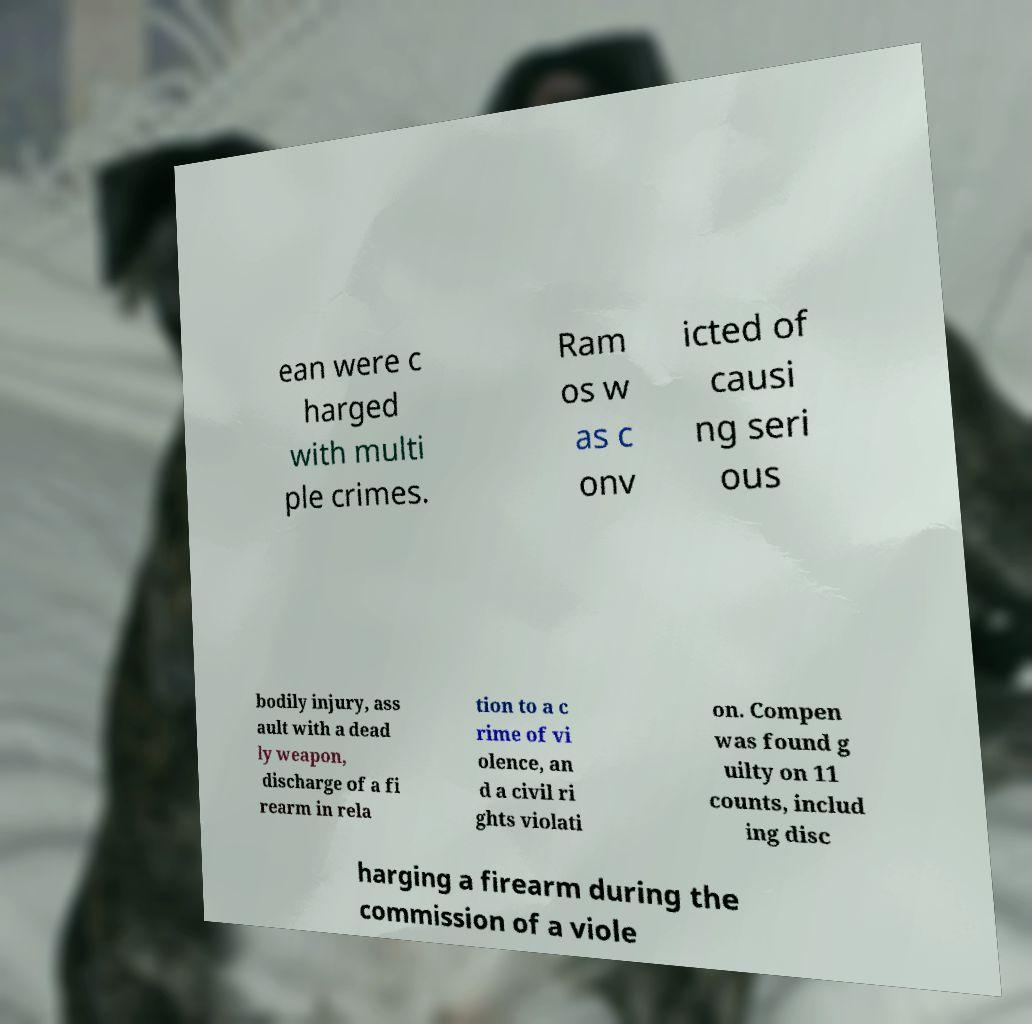Could you assist in decoding the text presented in this image and type it out clearly? ean were c harged with multi ple crimes. Ram os w as c onv icted of causi ng seri ous bodily injury, ass ault with a dead ly weapon, discharge of a fi rearm in rela tion to a c rime of vi olence, an d a civil ri ghts violati on. Compen was found g uilty on 11 counts, includ ing disc harging a firearm during the commission of a viole 